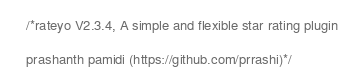Convert code to text. <code><loc_0><loc_0><loc_500><loc_500><_JavaScript_>/*rateyo V2.3.4, A simple and flexible star rating plugin
prashanth pamidi (https://github.com/prrashi)*/</code> 